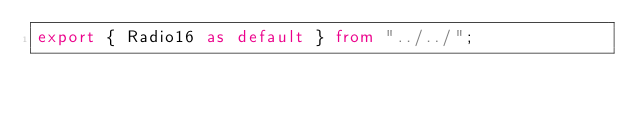Convert code to text. <code><loc_0><loc_0><loc_500><loc_500><_TypeScript_>export { Radio16 as default } from "../../";
</code> 